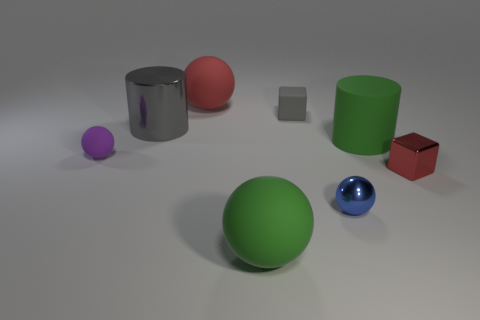Is the number of purple things greater than the number of small green metal spheres?
Provide a succinct answer. Yes. What number of objects are either cylinders that are right of the big gray metal cylinder or spheres?
Your answer should be compact. 5. What number of cubes are on the right side of the big object to the right of the gray cube?
Your answer should be very brief. 1. There is a matte thing in front of the small thing on the left side of the metallic thing behind the shiny block; what size is it?
Give a very brief answer. Large. There is a ball to the left of the red matte ball; is it the same color as the rubber cylinder?
Keep it short and to the point. No. There is a green thing that is the same shape as the gray metallic object; what is its size?
Offer a very short reply. Large. What number of objects are either red objects that are in front of the gray rubber thing or balls on the right side of the small purple matte object?
Provide a succinct answer. 4. What is the shape of the small shiny thing that is right of the green object on the right side of the blue metallic thing?
Your answer should be very brief. Cube. Is there any other thing that has the same color as the rubber block?
Provide a short and direct response. Yes. Is there any other thing that has the same size as the gray cylinder?
Your answer should be very brief. Yes. 